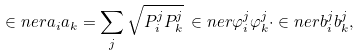Convert formula to latex. <formula><loc_0><loc_0><loc_500><loc_500>\in n e r { a _ { i } } { a _ { k } } = \sum _ { j } \sqrt { P _ { i } ^ { j } P _ { k } ^ { j } } \, \in n e r { \varphi _ { i } ^ { j } } { \varphi _ { k } ^ { j } } \cdot \in n e r { b _ { i } ^ { j } } { b _ { k } ^ { j } } ,</formula> 